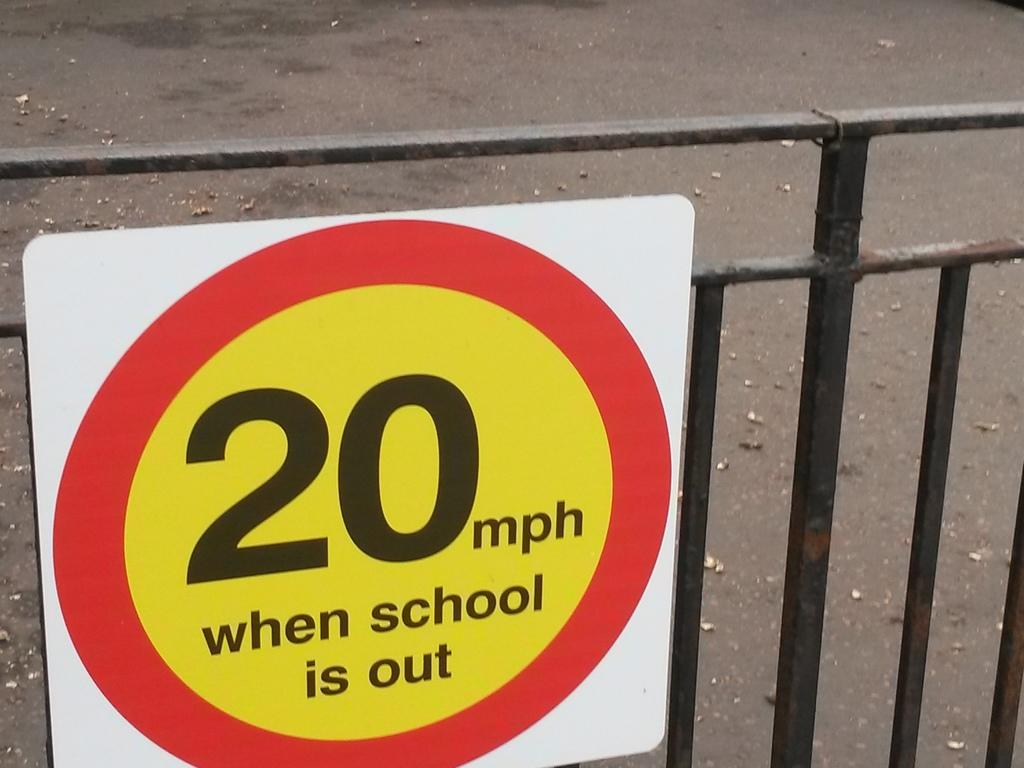<image>
Present a compact description of the photo's key features. the number 20 that is on a sign 